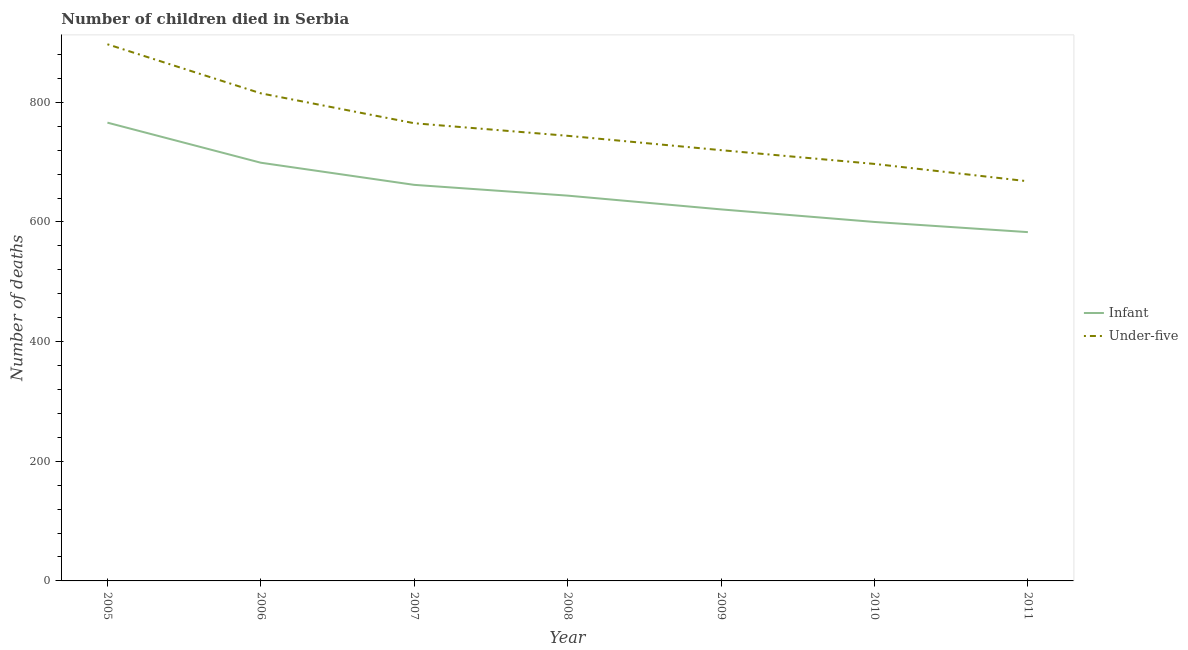How many different coloured lines are there?
Offer a terse response. 2. Does the line corresponding to number of under-five deaths intersect with the line corresponding to number of infant deaths?
Provide a succinct answer. No. What is the number of infant deaths in 2008?
Keep it short and to the point. 644. Across all years, what is the maximum number of under-five deaths?
Ensure brevity in your answer.  897. Across all years, what is the minimum number of infant deaths?
Give a very brief answer. 583. In which year was the number of under-five deaths maximum?
Offer a very short reply. 2005. What is the total number of under-five deaths in the graph?
Provide a succinct answer. 5306. What is the difference between the number of under-five deaths in 2005 and that in 2010?
Offer a terse response. 200. What is the difference between the number of under-five deaths in 2011 and the number of infant deaths in 2006?
Keep it short and to the point. -31. What is the average number of under-five deaths per year?
Offer a terse response. 758. In the year 2011, what is the difference between the number of under-five deaths and number of infant deaths?
Make the answer very short. 85. In how many years, is the number of under-five deaths greater than 600?
Give a very brief answer. 7. What is the ratio of the number of infant deaths in 2008 to that in 2011?
Offer a very short reply. 1.1. Is the difference between the number of under-five deaths in 2005 and 2006 greater than the difference between the number of infant deaths in 2005 and 2006?
Your response must be concise. Yes. What is the difference between the highest and the second highest number of infant deaths?
Your answer should be compact. 67. What is the difference between the highest and the lowest number of under-five deaths?
Your response must be concise. 229. Does the number of infant deaths monotonically increase over the years?
Your answer should be very brief. No. Is the number of under-five deaths strictly less than the number of infant deaths over the years?
Provide a short and direct response. No. Are the values on the major ticks of Y-axis written in scientific E-notation?
Provide a short and direct response. No. Where does the legend appear in the graph?
Ensure brevity in your answer.  Center right. How many legend labels are there?
Your response must be concise. 2. How are the legend labels stacked?
Make the answer very short. Vertical. What is the title of the graph?
Make the answer very short. Number of children died in Serbia. Does "UN agencies" appear as one of the legend labels in the graph?
Provide a short and direct response. No. What is the label or title of the X-axis?
Your response must be concise. Year. What is the label or title of the Y-axis?
Your answer should be compact. Number of deaths. What is the Number of deaths in Infant in 2005?
Your answer should be compact. 766. What is the Number of deaths of Under-five in 2005?
Give a very brief answer. 897. What is the Number of deaths in Infant in 2006?
Your answer should be very brief. 699. What is the Number of deaths of Under-five in 2006?
Your answer should be compact. 815. What is the Number of deaths of Infant in 2007?
Provide a succinct answer. 662. What is the Number of deaths of Under-five in 2007?
Offer a very short reply. 765. What is the Number of deaths of Infant in 2008?
Your response must be concise. 644. What is the Number of deaths of Under-five in 2008?
Your answer should be very brief. 744. What is the Number of deaths in Infant in 2009?
Your response must be concise. 621. What is the Number of deaths in Under-five in 2009?
Offer a very short reply. 720. What is the Number of deaths in Infant in 2010?
Provide a short and direct response. 600. What is the Number of deaths of Under-five in 2010?
Offer a terse response. 697. What is the Number of deaths of Infant in 2011?
Provide a short and direct response. 583. What is the Number of deaths of Under-five in 2011?
Keep it short and to the point. 668. Across all years, what is the maximum Number of deaths of Infant?
Your answer should be compact. 766. Across all years, what is the maximum Number of deaths in Under-five?
Make the answer very short. 897. Across all years, what is the minimum Number of deaths in Infant?
Offer a terse response. 583. Across all years, what is the minimum Number of deaths of Under-five?
Provide a short and direct response. 668. What is the total Number of deaths in Infant in the graph?
Make the answer very short. 4575. What is the total Number of deaths of Under-five in the graph?
Ensure brevity in your answer.  5306. What is the difference between the Number of deaths of Infant in 2005 and that in 2007?
Keep it short and to the point. 104. What is the difference between the Number of deaths in Under-five in 2005 and that in 2007?
Offer a very short reply. 132. What is the difference between the Number of deaths of Infant in 2005 and that in 2008?
Ensure brevity in your answer.  122. What is the difference between the Number of deaths in Under-five in 2005 and that in 2008?
Provide a succinct answer. 153. What is the difference between the Number of deaths in Infant in 2005 and that in 2009?
Offer a very short reply. 145. What is the difference between the Number of deaths of Under-five in 2005 and that in 2009?
Provide a short and direct response. 177. What is the difference between the Number of deaths in Infant in 2005 and that in 2010?
Your answer should be compact. 166. What is the difference between the Number of deaths in Infant in 2005 and that in 2011?
Offer a very short reply. 183. What is the difference between the Number of deaths of Under-five in 2005 and that in 2011?
Provide a short and direct response. 229. What is the difference between the Number of deaths of Under-five in 2006 and that in 2007?
Provide a short and direct response. 50. What is the difference between the Number of deaths in Under-five in 2006 and that in 2008?
Your response must be concise. 71. What is the difference between the Number of deaths of Under-five in 2006 and that in 2009?
Offer a terse response. 95. What is the difference between the Number of deaths of Infant in 2006 and that in 2010?
Make the answer very short. 99. What is the difference between the Number of deaths of Under-five in 2006 and that in 2010?
Offer a very short reply. 118. What is the difference between the Number of deaths of Infant in 2006 and that in 2011?
Provide a succinct answer. 116. What is the difference between the Number of deaths in Under-five in 2006 and that in 2011?
Offer a terse response. 147. What is the difference between the Number of deaths in Under-five in 2007 and that in 2009?
Your response must be concise. 45. What is the difference between the Number of deaths of Under-five in 2007 and that in 2010?
Your answer should be compact. 68. What is the difference between the Number of deaths of Infant in 2007 and that in 2011?
Provide a short and direct response. 79. What is the difference between the Number of deaths in Under-five in 2007 and that in 2011?
Provide a succinct answer. 97. What is the difference between the Number of deaths in Infant in 2008 and that in 2009?
Make the answer very short. 23. What is the difference between the Number of deaths in Under-five in 2008 and that in 2009?
Your response must be concise. 24. What is the difference between the Number of deaths of Infant in 2008 and that in 2011?
Keep it short and to the point. 61. What is the difference between the Number of deaths of Under-five in 2008 and that in 2011?
Give a very brief answer. 76. What is the difference between the Number of deaths of Under-five in 2009 and that in 2011?
Offer a terse response. 52. What is the difference between the Number of deaths in Under-five in 2010 and that in 2011?
Your answer should be very brief. 29. What is the difference between the Number of deaths in Infant in 2005 and the Number of deaths in Under-five in 2006?
Your answer should be very brief. -49. What is the difference between the Number of deaths of Infant in 2005 and the Number of deaths of Under-five in 2011?
Provide a succinct answer. 98. What is the difference between the Number of deaths of Infant in 2006 and the Number of deaths of Under-five in 2007?
Keep it short and to the point. -66. What is the difference between the Number of deaths of Infant in 2006 and the Number of deaths of Under-five in 2008?
Your answer should be very brief. -45. What is the difference between the Number of deaths in Infant in 2006 and the Number of deaths in Under-five in 2009?
Your response must be concise. -21. What is the difference between the Number of deaths of Infant in 2007 and the Number of deaths of Under-five in 2008?
Your response must be concise. -82. What is the difference between the Number of deaths in Infant in 2007 and the Number of deaths in Under-five in 2009?
Offer a terse response. -58. What is the difference between the Number of deaths in Infant in 2007 and the Number of deaths in Under-five in 2010?
Provide a short and direct response. -35. What is the difference between the Number of deaths of Infant in 2007 and the Number of deaths of Under-five in 2011?
Your response must be concise. -6. What is the difference between the Number of deaths in Infant in 2008 and the Number of deaths in Under-five in 2009?
Your answer should be very brief. -76. What is the difference between the Number of deaths of Infant in 2008 and the Number of deaths of Under-five in 2010?
Ensure brevity in your answer.  -53. What is the difference between the Number of deaths in Infant in 2009 and the Number of deaths in Under-five in 2010?
Ensure brevity in your answer.  -76. What is the difference between the Number of deaths in Infant in 2009 and the Number of deaths in Under-five in 2011?
Give a very brief answer. -47. What is the difference between the Number of deaths in Infant in 2010 and the Number of deaths in Under-five in 2011?
Ensure brevity in your answer.  -68. What is the average Number of deaths in Infant per year?
Offer a very short reply. 653.57. What is the average Number of deaths of Under-five per year?
Your answer should be compact. 758. In the year 2005, what is the difference between the Number of deaths in Infant and Number of deaths in Under-five?
Keep it short and to the point. -131. In the year 2006, what is the difference between the Number of deaths of Infant and Number of deaths of Under-five?
Offer a very short reply. -116. In the year 2007, what is the difference between the Number of deaths of Infant and Number of deaths of Under-five?
Provide a succinct answer. -103. In the year 2008, what is the difference between the Number of deaths in Infant and Number of deaths in Under-five?
Your response must be concise. -100. In the year 2009, what is the difference between the Number of deaths of Infant and Number of deaths of Under-five?
Provide a succinct answer. -99. In the year 2010, what is the difference between the Number of deaths of Infant and Number of deaths of Under-five?
Offer a terse response. -97. In the year 2011, what is the difference between the Number of deaths in Infant and Number of deaths in Under-five?
Your response must be concise. -85. What is the ratio of the Number of deaths of Infant in 2005 to that in 2006?
Offer a terse response. 1.1. What is the ratio of the Number of deaths in Under-five in 2005 to that in 2006?
Provide a short and direct response. 1.1. What is the ratio of the Number of deaths in Infant in 2005 to that in 2007?
Offer a very short reply. 1.16. What is the ratio of the Number of deaths in Under-five in 2005 to that in 2007?
Provide a succinct answer. 1.17. What is the ratio of the Number of deaths in Infant in 2005 to that in 2008?
Your answer should be very brief. 1.19. What is the ratio of the Number of deaths in Under-five in 2005 to that in 2008?
Ensure brevity in your answer.  1.21. What is the ratio of the Number of deaths in Infant in 2005 to that in 2009?
Your answer should be very brief. 1.23. What is the ratio of the Number of deaths of Under-five in 2005 to that in 2009?
Your response must be concise. 1.25. What is the ratio of the Number of deaths of Infant in 2005 to that in 2010?
Your answer should be very brief. 1.28. What is the ratio of the Number of deaths of Under-five in 2005 to that in 2010?
Make the answer very short. 1.29. What is the ratio of the Number of deaths of Infant in 2005 to that in 2011?
Keep it short and to the point. 1.31. What is the ratio of the Number of deaths in Under-five in 2005 to that in 2011?
Offer a very short reply. 1.34. What is the ratio of the Number of deaths in Infant in 2006 to that in 2007?
Make the answer very short. 1.06. What is the ratio of the Number of deaths of Under-five in 2006 to that in 2007?
Your response must be concise. 1.07. What is the ratio of the Number of deaths of Infant in 2006 to that in 2008?
Make the answer very short. 1.09. What is the ratio of the Number of deaths in Under-five in 2006 to that in 2008?
Provide a short and direct response. 1.1. What is the ratio of the Number of deaths in Infant in 2006 to that in 2009?
Offer a terse response. 1.13. What is the ratio of the Number of deaths in Under-five in 2006 to that in 2009?
Ensure brevity in your answer.  1.13. What is the ratio of the Number of deaths of Infant in 2006 to that in 2010?
Your answer should be very brief. 1.17. What is the ratio of the Number of deaths of Under-five in 2006 to that in 2010?
Offer a very short reply. 1.17. What is the ratio of the Number of deaths of Infant in 2006 to that in 2011?
Make the answer very short. 1.2. What is the ratio of the Number of deaths of Under-five in 2006 to that in 2011?
Your answer should be compact. 1.22. What is the ratio of the Number of deaths in Infant in 2007 to that in 2008?
Give a very brief answer. 1.03. What is the ratio of the Number of deaths in Under-five in 2007 to that in 2008?
Keep it short and to the point. 1.03. What is the ratio of the Number of deaths in Infant in 2007 to that in 2009?
Keep it short and to the point. 1.07. What is the ratio of the Number of deaths in Infant in 2007 to that in 2010?
Keep it short and to the point. 1.1. What is the ratio of the Number of deaths of Under-five in 2007 to that in 2010?
Provide a succinct answer. 1.1. What is the ratio of the Number of deaths of Infant in 2007 to that in 2011?
Keep it short and to the point. 1.14. What is the ratio of the Number of deaths of Under-five in 2007 to that in 2011?
Make the answer very short. 1.15. What is the ratio of the Number of deaths of Infant in 2008 to that in 2009?
Ensure brevity in your answer.  1.04. What is the ratio of the Number of deaths of Under-five in 2008 to that in 2009?
Give a very brief answer. 1.03. What is the ratio of the Number of deaths in Infant in 2008 to that in 2010?
Provide a short and direct response. 1.07. What is the ratio of the Number of deaths of Under-five in 2008 to that in 2010?
Ensure brevity in your answer.  1.07. What is the ratio of the Number of deaths of Infant in 2008 to that in 2011?
Your answer should be very brief. 1.1. What is the ratio of the Number of deaths of Under-five in 2008 to that in 2011?
Make the answer very short. 1.11. What is the ratio of the Number of deaths in Infant in 2009 to that in 2010?
Offer a very short reply. 1.03. What is the ratio of the Number of deaths in Under-five in 2009 to that in 2010?
Offer a very short reply. 1.03. What is the ratio of the Number of deaths of Infant in 2009 to that in 2011?
Provide a short and direct response. 1.07. What is the ratio of the Number of deaths in Under-five in 2009 to that in 2011?
Provide a succinct answer. 1.08. What is the ratio of the Number of deaths of Infant in 2010 to that in 2011?
Give a very brief answer. 1.03. What is the ratio of the Number of deaths of Under-five in 2010 to that in 2011?
Offer a very short reply. 1.04. What is the difference between the highest and the lowest Number of deaths of Infant?
Offer a terse response. 183. What is the difference between the highest and the lowest Number of deaths in Under-five?
Provide a succinct answer. 229. 